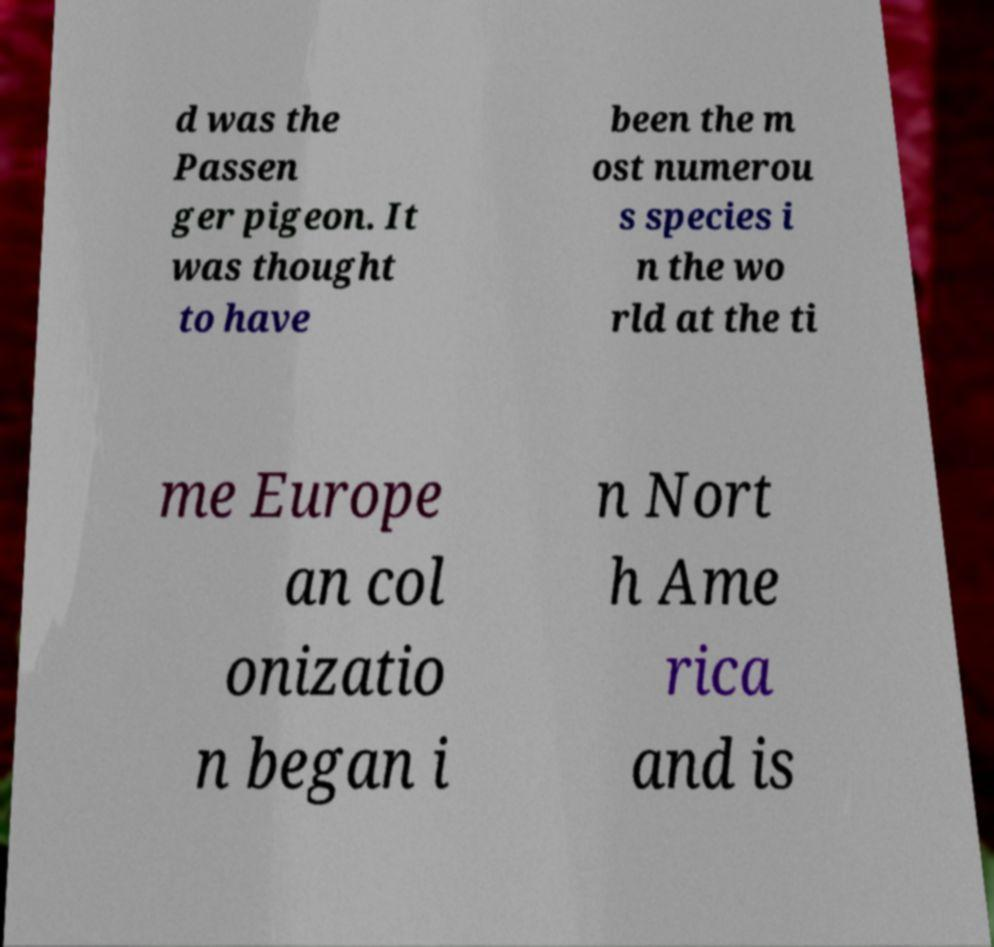There's text embedded in this image that I need extracted. Can you transcribe it verbatim? d was the Passen ger pigeon. It was thought to have been the m ost numerou s species i n the wo rld at the ti me Europe an col onizatio n began i n Nort h Ame rica and is 